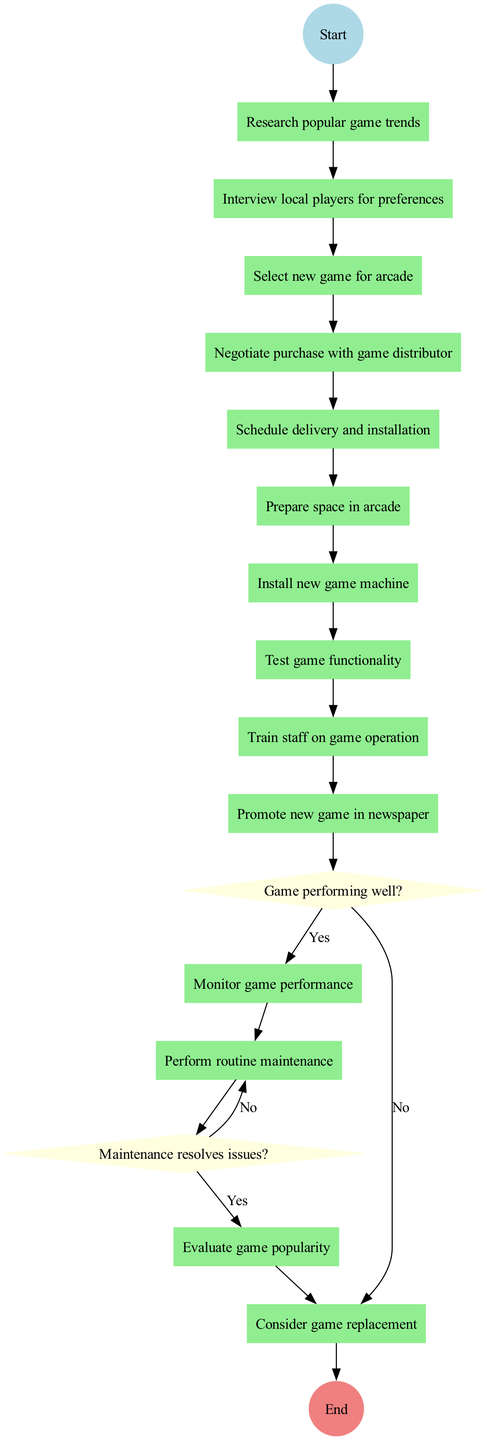What is the first activity in the diagram? The diagram starts at the "Start" node and branches into the first activity, which is "Research popular game trends."
Answer: Research popular game trends How many activities are listed in the diagram? Counting the activities in the diagram, there are a total of 13 activities from research to replacement.
Answer: 13 What decision occurs after promoting the new game? After the "Promote new game in newspaper" activity, the decision node is "Game performing well?" which assesses the performance of the new game.
Answer: Game performing well? What action follows a negative response to the maintenance check? If the maintenance does not resolve issues at the "Perform routine maintenance" activity, the next action is to "Contact technical support."
Answer: Contact technical support What happens if the game is evaluated as unpopular? If the game is determined to be unpopular based on the decision node, the flow moves to "Consider game replacement."
Answer: Consider game replacement Which activity directly precedes "Test game functionality"? "Install new game machine" is the activity that directly precedes "Test game functionality" in the flow of the diagram.
Answer: Install new game machine Is there any activity that follows directly after "Train staff on game operation"? Yes, the activity that follows "Train staff on game operation" is "Promote new game in newspaper."
Answer: Promote new game in newspaper What is the last node in the lifecycle flow? The final node in the diagram, after going through all the defined activities and decisions, is "End."
Answer: End What happens if the game is performing well? If the game is performing well, the flow continues with "Continue monitoring" and does not lead to replacement.
Answer: Continue monitoring 